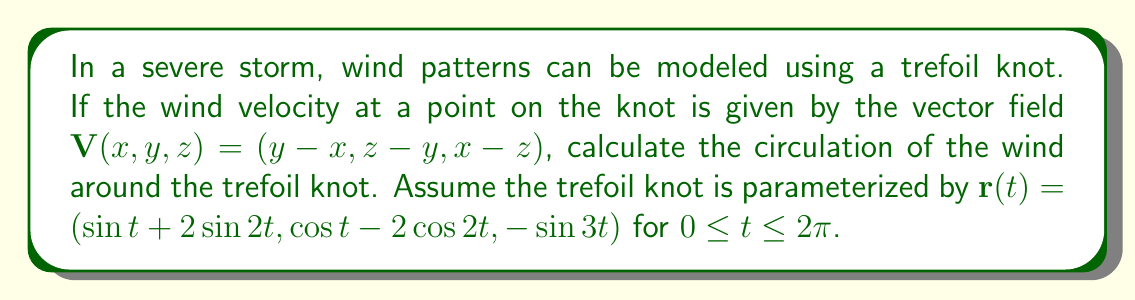Can you answer this question? To calculate the circulation of the wind around the trefoil knot, we need to evaluate the line integral of the vector field $\mathbf{V}$ along the trefoil knot. We'll use the formula:

$$\oint_C \mathbf{V} \cdot d\mathbf{r}$$

Step 1: Calculate $d\mathbf{r}/dt$
$$\frac{d\mathbf{r}}{dt} = (\cos t + 4 \cos 2t, -\sin t + 4 \sin 2t, -3 \cos 3t)$$

Step 2: Evaluate $\mathbf{V}(\mathbf{r}(t))$
$$\mathbf{V}(\mathbf{r}(t)) = (\cos t - 2 \cos 2t - \sin t - 2 \sin 2t, -\sin 3t - \cos t + 2 \cos 2t, \sin t + 2 \sin 2t + \sin 3t)$$

Step 3: Calculate the dot product $\mathbf{V}(\mathbf{r}(t)) \cdot \frac{d\mathbf{r}}{dt}$
$$\mathbf{V}(\mathbf{r}(t)) \cdot \frac{d\mathbf{r}}{dt} = (\cos t - 2 \cos 2t - \sin t - 2 \sin 2t)(\cos t + 4 \cos 2t) + $$
$$(-\sin 3t - \cos t + 2 \cos 2t)(-\sin t + 4 \sin 2t) + $$
$$(\sin t + 2 \sin 2t + \sin 3t)(-3 \cos 3t)$$

Step 4: Simplify and integrate from 0 to $2\pi$
After simplification, many terms cancel out or integrate to zero over a full period. The remaining terms are:

$$\int_0^{2\pi} (8 \cos^2 2t + 8 \sin^2 2t - 3 \sin 3t \cos 3t) dt$$

$$= \int_0^{2\pi} (8 - 3 \sin 3t \cos 3t) dt$$

$$= 16\pi - 3 \int_0^{2\pi} \sin 3t \cos 3t dt$$

The integral of $\sin 3t \cos 3t$ over a full period is zero, so we're left with:

$$\text{Circulation} = 16\pi$$
Answer: $16\pi$ 